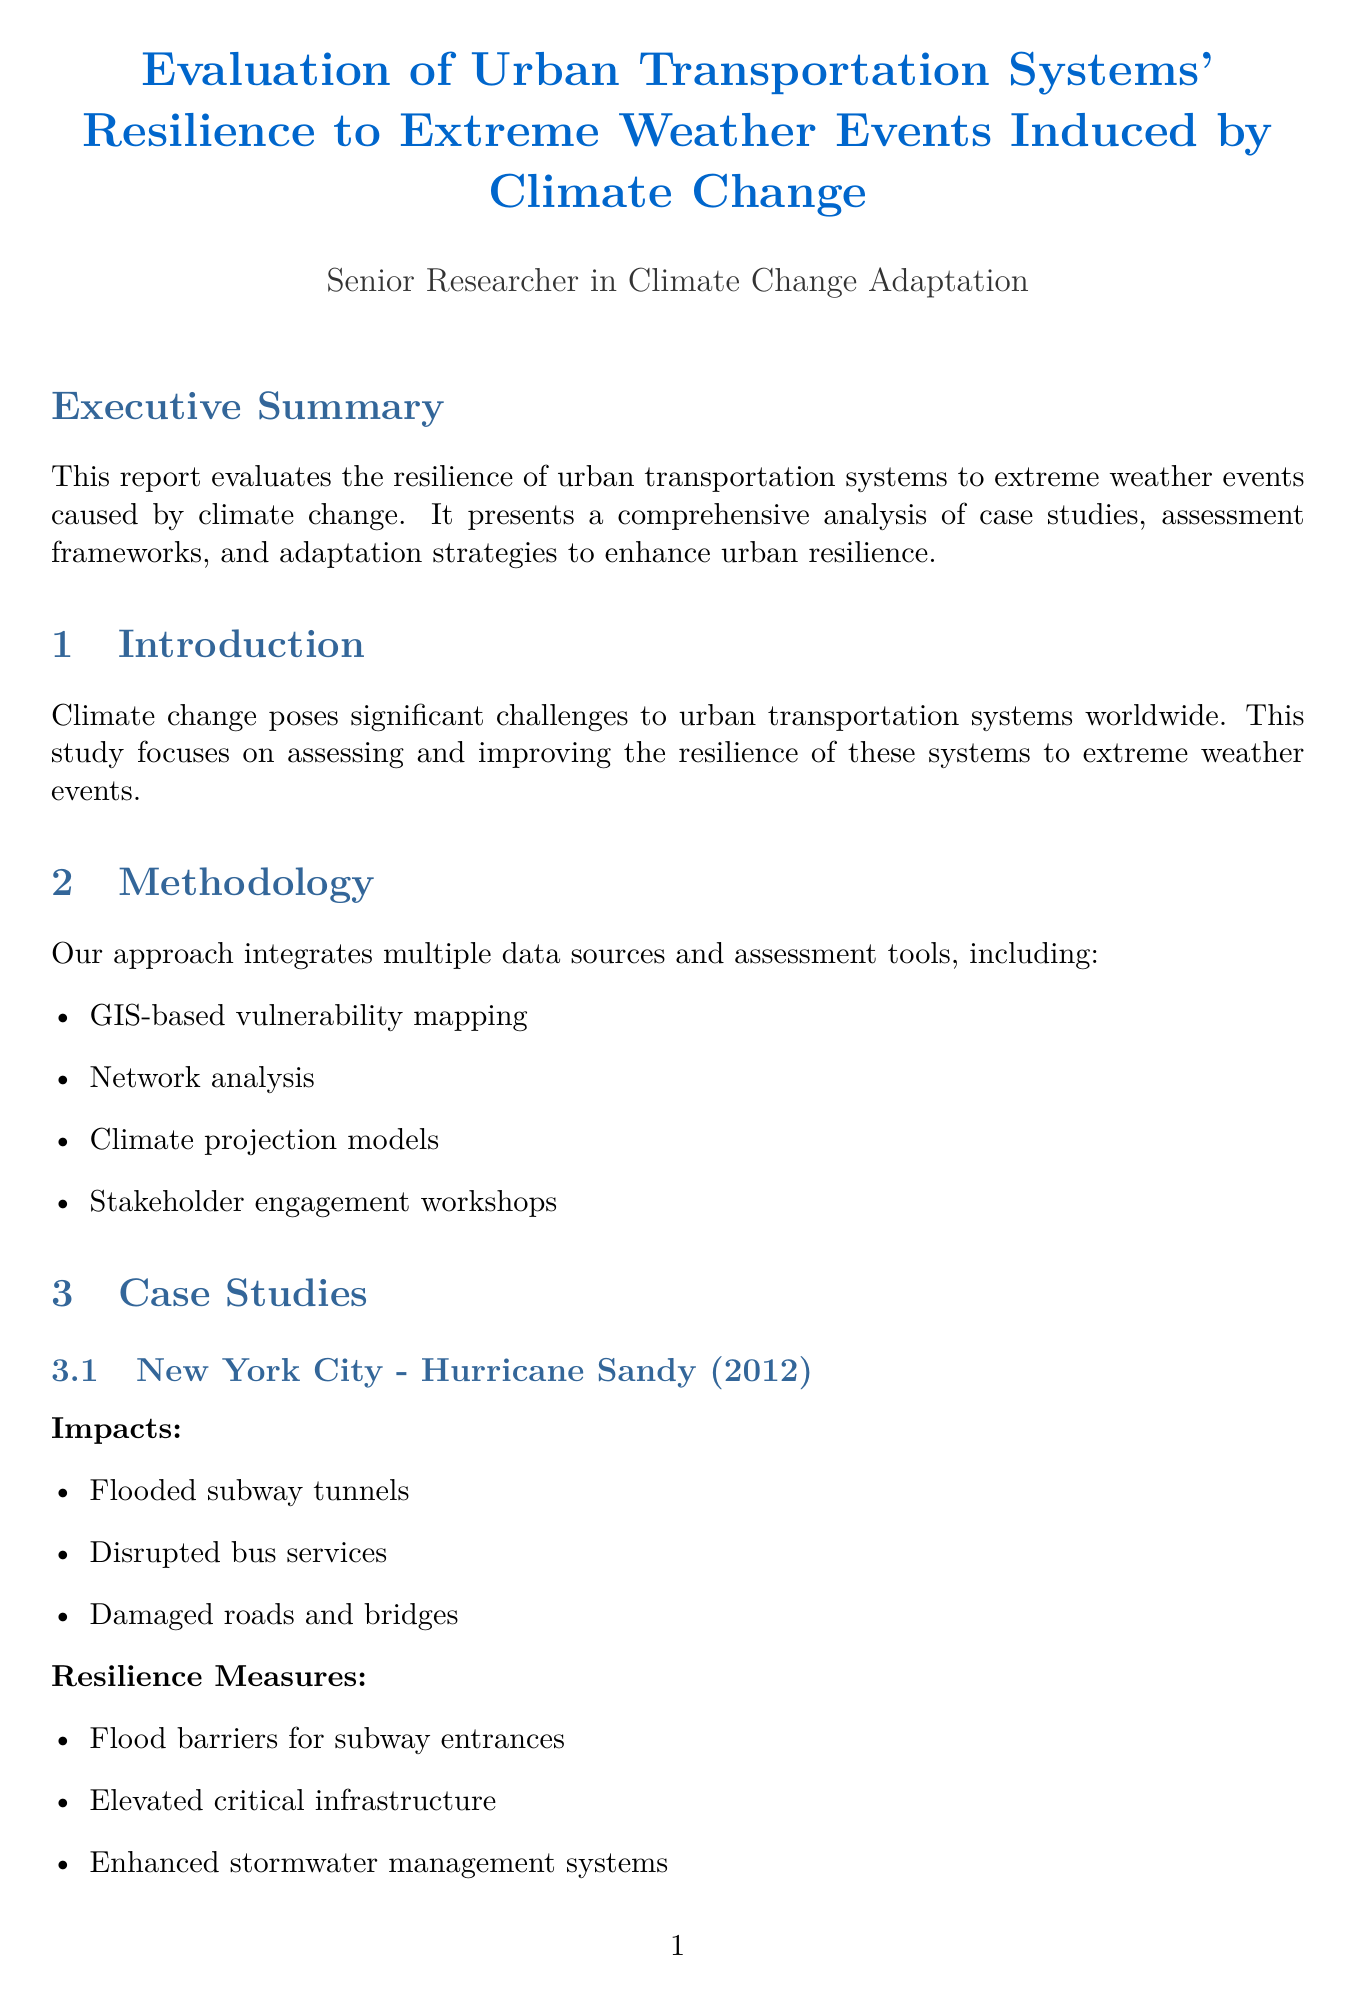What is the main focus of the report? The main focus of the report is to evaluate the resilience of urban transportation systems to extreme weather events caused by climate change.
Answer: Resilience of urban transportation systems What city is associated with Hurricane Sandy? Hurricane Sandy is associated with the case study involving New York City.
Answer: New York City Which event impacted Tokyo in 2019? The event that impacted Tokyo in 2019 was Typhoon Hagibis.
Answer: Typhoon Hagibis What is one resilience measure implemented in New York City? One resilience measure implemented in New York City is flood barriers for subway entrances.
Answer: Flood barriers for subway entrances How many key indicators are listed in the resilience assessment framework? The resilience assessment framework lists four key indicators.
Answer: Four What type of materials are suggested for road surfaces in adaptation strategies? Heat-resistant materials are suggested for road surfaces.
Answer: Heat-resistant materials Which research institution focuses on transportation challenges? The Transportation Research Board (TRB) focuses on transportation challenges.
Answer: Transportation Research Board (TRB) What is one adaptation strategy under policy and planning? One adaptation strategy under policy and planning is the integration of climate resilience in urban transportation plans.
Answer: Integration of climate resilience in urban transportation plans What year was the publication "Adapting Urban Transport to Climate Change" released? The publication "Adapting Urban Transport to Climate Change" was released in 2019.
Answer: 2019 What type of tools are included in the methodology section? The methodology section includes GIS-based vulnerability mapping as one of the tools.
Answer: GIS-based vulnerability mapping 